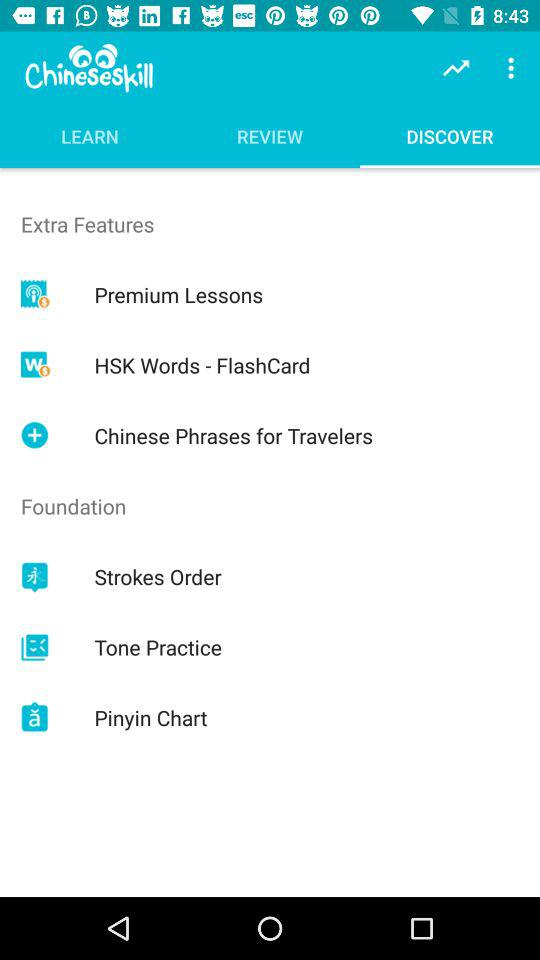What is the name of the application? The name of the application is "Chineseskill". 